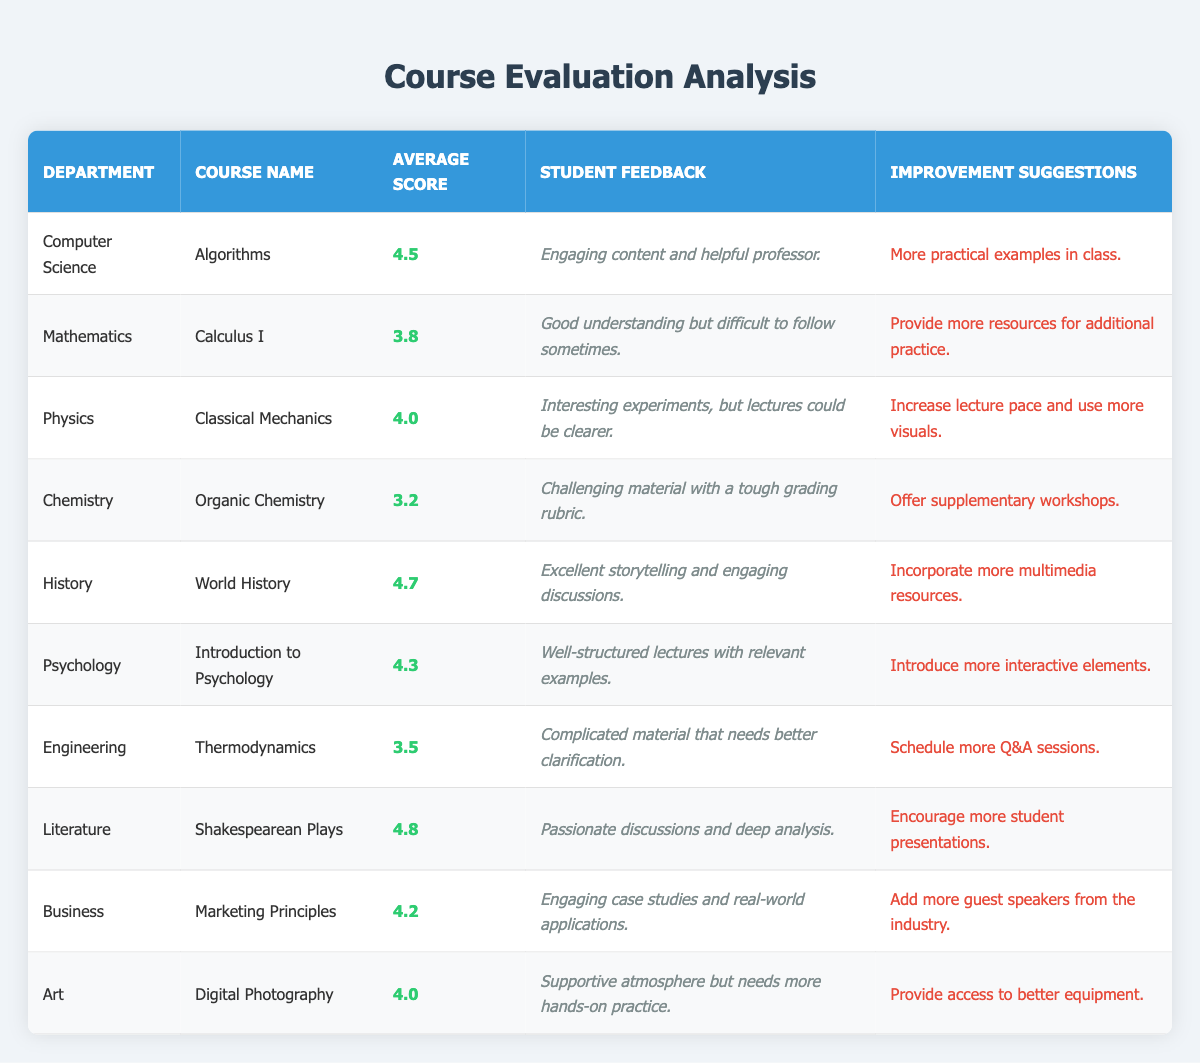What is the highest average score in the table? The highest average score can be found by inspecting the "Average Score" column. The values are 4.5, 3.8, 4.0, 3.2, 4.7, 4.3, 3.5, 4.8, 4.2, and 4.0. By comparing these values, we see that 4.8 for "Shakespearean Plays" in the Literature department is the highest.
Answer: 4.8 What department has the lowest average score? Looking through the "Average Score" column, the lowest score among the values 4.5, 3.8, 4.0, 3.2, 4.7, 4.3, 3.5, 4.8, 4.2, and 4.0 is 3.2, which corresponds to the "Organic Chemistry" course in the Chemistry department.
Answer: Chemistry How many courses have an average score above 4.0? By counting the courses with scores greater than 4.0 from the provided averages, we have Algorithms (4.5), Classical Mechanics (4.0), World History (4.7), Introduction to Psychology (4.3), Shakespearean Plays (4.8), and Marketing Principles (4.2). Thus, there are 6 courses that meet this criterion.
Answer: 6 Which department offers the course with the longest improvement suggestion? To determine this, we must look at the "Improvement Suggestions" column and compare the length of each response. The longest suggestion comes from the Chemistry department with "Offer supplementary workshops" which is 36 characters long. The other improvement suggestions are shorter.
Answer: Chemistry Is there a course in the Business department with a score lower than 4.0? In the "Average Score" column, the Business department's course "Marketing Principles" has an average score of 4.2. Since this score is greater than 4.0, the answer is no, there is not a course with a score lower than 4.0.
Answer: No What are the average scores of the Psychology and Art departments combined? The average scores of the Psychology department (4.3) and the Art department (4.0) need to be summed and then divided by the number of departments (which is 2). The calculation is (4.3 + 4.0) / 2 = 4.15. Thus, the combined average score is 4.15.
Answer: 4.15 Which course has ratings related to a supportive atmosphere? The course related to a supportive atmosphere is "Digital Photography" in the Art department, which has student feedback indicating that it creates a supportive atmosphere but requires more hands-on practice.
Answer: Digital Photography How many improvement suggestions recommend additional resources? Looking at the "Improvement Suggestions" column, the suggestions that recommend additional resources are from the Mathematics department ("Provide more resources for additional practice") and the Chemistry department ("Offer supplementary workshops"). This gives us a total of 2 courses with such suggestions.
Answer: 2 